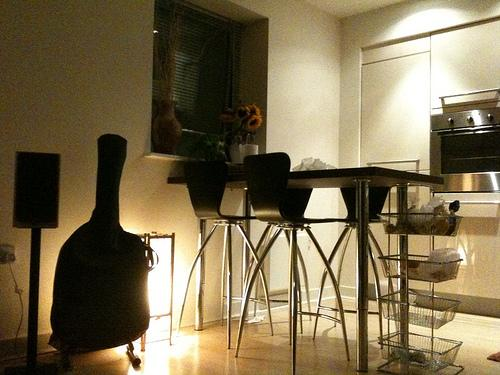What kind of musical instrument is covered by the guitar on the left side of the room?

Choices:
A) guitar
B) piano
C) violin
D) bass guitar 